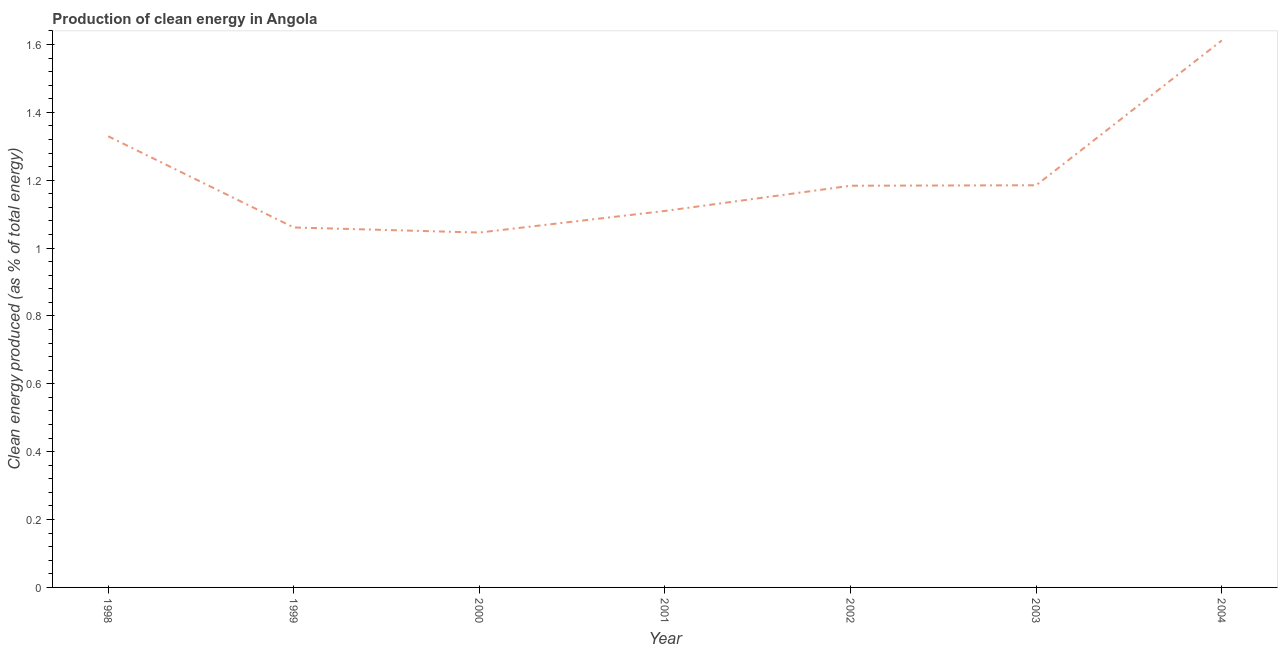What is the production of clean energy in 2000?
Provide a short and direct response. 1.05. Across all years, what is the maximum production of clean energy?
Your answer should be very brief. 1.61. Across all years, what is the minimum production of clean energy?
Ensure brevity in your answer.  1.05. In which year was the production of clean energy maximum?
Keep it short and to the point. 2004. What is the sum of the production of clean energy?
Keep it short and to the point. 8.53. What is the difference between the production of clean energy in 2002 and 2004?
Your answer should be compact. -0.43. What is the average production of clean energy per year?
Make the answer very short. 1.22. What is the median production of clean energy?
Provide a succinct answer. 1.18. In how many years, is the production of clean energy greater than 0.7600000000000001 %?
Your response must be concise. 7. Do a majority of the years between 1998 and 1999 (inclusive) have production of clean energy greater than 1.56 %?
Keep it short and to the point. No. What is the ratio of the production of clean energy in 1998 to that in 2004?
Make the answer very short. 0.82. Is the production of clean energy in 2000 less than that in 2002?
Ensure brevity in your answer.  Yes. What is the difference between the highest and the second highest production of clean energy?
Offer a very short reply. 0.28. What is the difference between the highest and the lowest production of clean energy?
Your answer should be very brief. 0.57. In how many years, is the production of clean energy greater than the average production of clean energy taken over all years?
Your answer should be very brief. 2. How many years are there in the graph?
Your answer should be very brief. 7. What is the title of the graph?
Give a very brief answer. Production of clean energy in Angola. What is the label or title of the X-axis?
Ensure brevity in your answer.  Year. What is the label or title of the Y-axis?
Your answer should be compact. Clean energy produced (as % of total energy). What is the Clean energy produced (as % of total energy) of 1998?
Offer a very short reply. 1.33. What is the Clean energy produced (as % of total energy) in 1999?
Keep it short and to the point. 1.06. What is the Clean energy produced (as % of total energy) of 2000?
Provide a short and direct response. 1.05. What is the Clean energy produced (as % of total energy) of 2001?
Give a very brief answer. 1.11. What is the Clean energy produced (as % of total energy) of 2002?
Ensure brevity in your answer.  1.18. What is the Clean energy produced (as % of total energy) of 2003?
Offer a terse response. 1.19. What is the Clean energy produced (as % of total energy) of 2004?
Provide a succinct answer. 1.61. What is the difference between the Clean energy produced (as % of total energy) in 1998 and 1999?
Give a very brief answer. 0.27. What is the difference between the Clean energy produced (as % of total energy) in 1998 and 2000?
Ensure brevity in your answer.  0.28. What is the difference between the Clean energy produced (as % of total energy) in 1998 and 2001?
Make the answer very short. 0.22. What is the difference between the Clean energy produced (as % of total energy) in 1998 and 2002?
Offer a terse response. 0.15. What is the difference between the Clean energy produced (as % of total energy) in 1998 and 2003?
Your answer should be very brief. 0.14. What is the difference between the Clean energy produced (as % of total energy) in 1998 and 2004?
Offer a very short reply. -0.28. What is the difference between the Clean energy produced (as % of total energy) in 1999 and 2000?
Provide a short and direct response. 0.01. What is the difference between the Clean energy produced (as % of total energy) in 1999 and 2001?
Provide a short and direct response. -0.05. What is the difference between the Clean energy produced (as % of total energy) in 1999 and 2002?
Ensure brevity in your answer.  -0.12. What is the difference between the Clean energy produced (as % of total energy) in 1999 and 2003?
Your response must be concise. -0.12. What is the difference between the Clean energy produced (as % of total energy) in 1999 and 2004?
Ensure brevity in your answer.  -0.55. What is the difference between the Clean energy produced (as % of total energy) in 2000 and 2001?
Offer a very short reply. -0.06. What is the difference between the Clean energy produced (as % of total energy) in 2000 and 2002?
Provide a short and direct response. -0.14. What is the difference between the Clean energy produced (as % of total energy) in 2000 and 2003?
Ensure brevity in your answer.  -0.14. What is the difference between the Clean energy produced (as % of total energy) in 2000 and 2004?
Your answer should be very brief. -0.57. What is the difference between the Clean energy produced (as % of total energy) in 2001 and 2002?
Offer a very short reply. -0.07. What is the difference between the Clean energy produced (as % of total energy) in 2001 and 2003?
Make the answer very short. -0.08. What is the difference between the Clean energy produced (as % of total energy) in 2001 and 2004?
Make the answer very short. -0.5. What is the difference between the Clean energy produced (as % of total energy) in 2002 and 2003?
Make the answer very short. -0. What is the difference between the Clean energy produced (as % of total energy) in 2002 and 2004?
Offer a terse response. -0.43. What is the difference between the Clean energy produced (as % of total energy) in 2003 and 2004?
Provide a short and direct response. -0.43. What is the ratio of the Clean energy produced (as % of total energy) in 1998 to that in 1999?
Ensure brevity in your answer.  1.25. What is the ratio of the Clean energy produced (as % of total energy) in 1998 to that in 2000?
Your answer should be compact. 1.27. What is the ratio of the Clean energy produced (as % of total energy) in 1998 to that in 2001?
Offer a terse response. 1.2. What is the ratio of the Clean energy produced (as % of total energy) in 1998 to that in 2002?
Provide a succinct answer. 1.12. What is the ratio of the Clean energy produced (as % of total energy) in 1998 to that in 2003?
Your answer should be compact. 1.12. What is the ratio of the Clean energy produced (as % of total energy) in 1998 to that in 2004?
Give a very brief answer. 0.82. What is the ratio of the Clean energy produced (as % of total energy) in 1999 to that in 2000?
Your answer should be compact. 1.01. What is the ratio of the Clean energy produced (as % of total energy) in 1999 to that in 2001?
Your answer should be compact. 0.96. What is the ratio of the Clean energy produced (as % of total energy) in 1999 to that in 2002?
Your answer should be very brief. 0.9. What is the ratio of the Clean energy produced (as % of total energy) in 1999 to that in 2003?
Provide a succinct answer. 0.9. What is the ratio of the Clean energy produced (as % of total energy) in 1999 to that in 2004?
Make the answer very short. 0.66. What is the ratio of the Clean energy produced (as % of total energy) in 2000 to that in 2001?
Keep it short and to the point. 0.94. What is the ratio of the Clean energy produced (as % of total energy) in 2000 to that in 2002?
Offer a very short reply. 0.88. What is the ratio of the Clean energy produced (as % of total energy) in 2000 to that in 2003?
Ensure brevity in your answer.  0.88. What is the ratio of the Clean energy produced (as % of total energy) in 2000 to that in 2004?
Your response must be concise. 0.65. What is the ratio of the Clean energy produced (as % of total energy) in 2001 to that in 2002?
Offer a very short reply. 0.94. What is the ratio of the Clean energy produced (as % of total energy) in 2001 to that in 2003?
Offer a terse response. 0.94. What is the ratio of the Clean energy produced (as % of total energy) in 2001 to that in 2004?
Your answer should be compact. 0.69. What is the ratio of the Clean energy produced (as % of total energy) in 2002 to that in 2004?
Your answer should be very brief. 0.73. What is the ratio of the Clean energy produced (as % of total energy) in 2003 to that in 2004?
Keep it short and to the point. 0.73. 